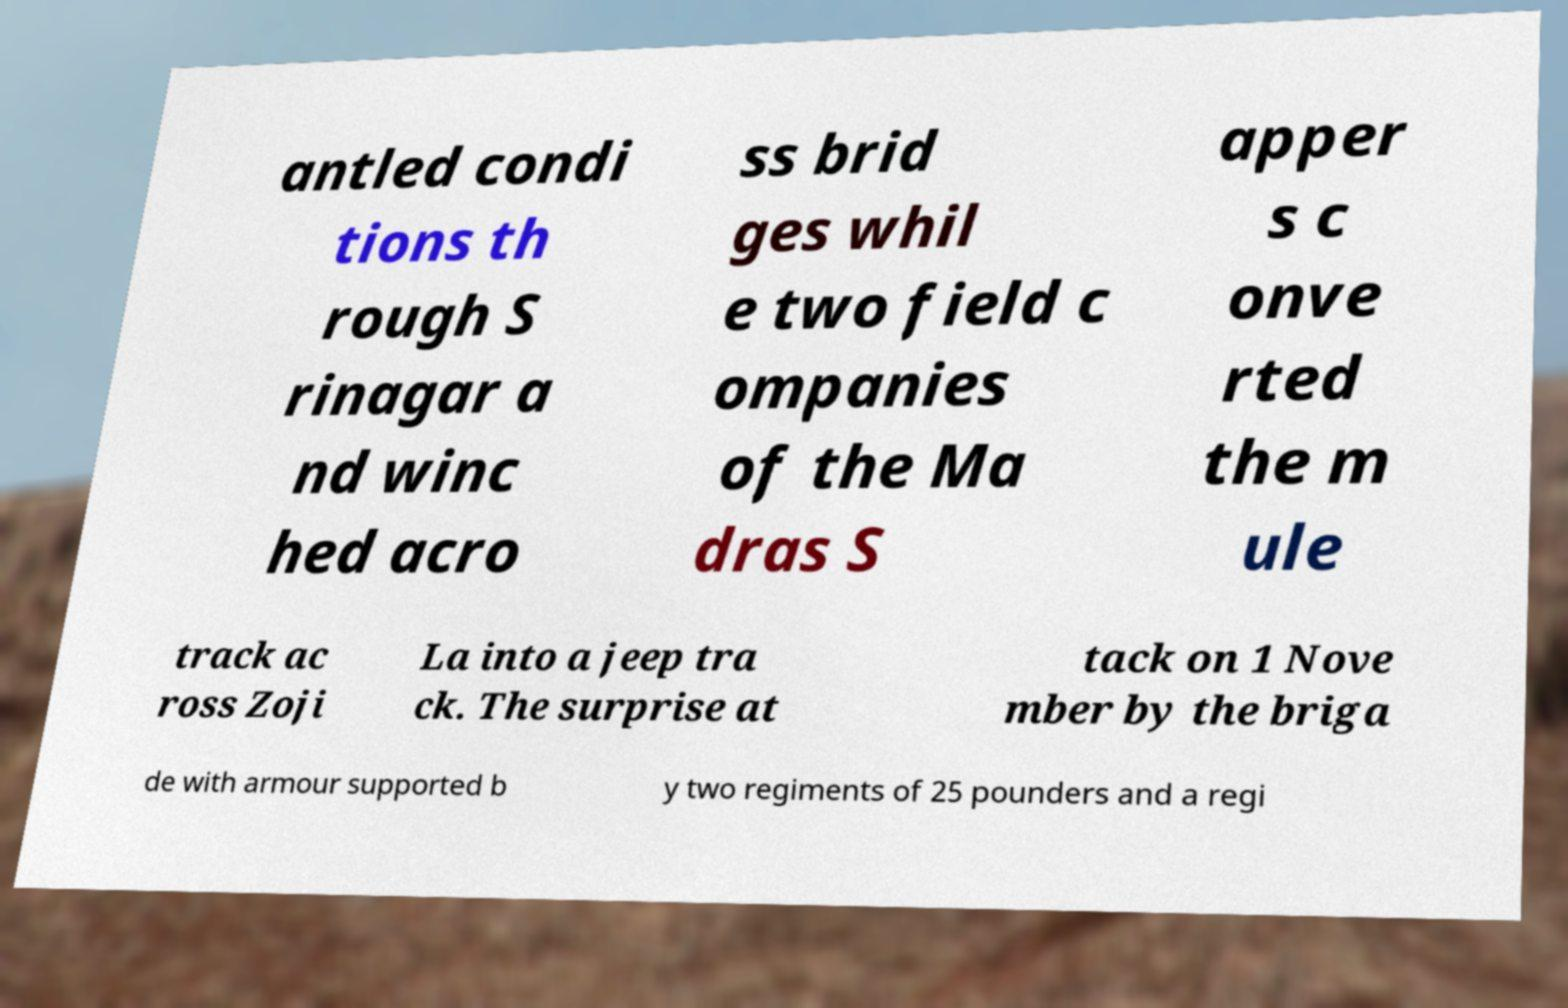Could you extract and type out the text from this image? antled condi tions th rough S rinagar a nd winc hed acro ss brid ges whil e two field c ompanies of the Ma dras S apper s c onve rted the m ule track ac ross Zoji La into a jeep tra ck. The surprise at tack on 1 Nove mber by the briga de with armour supported b y two regiments of 25 pounders and a regi 